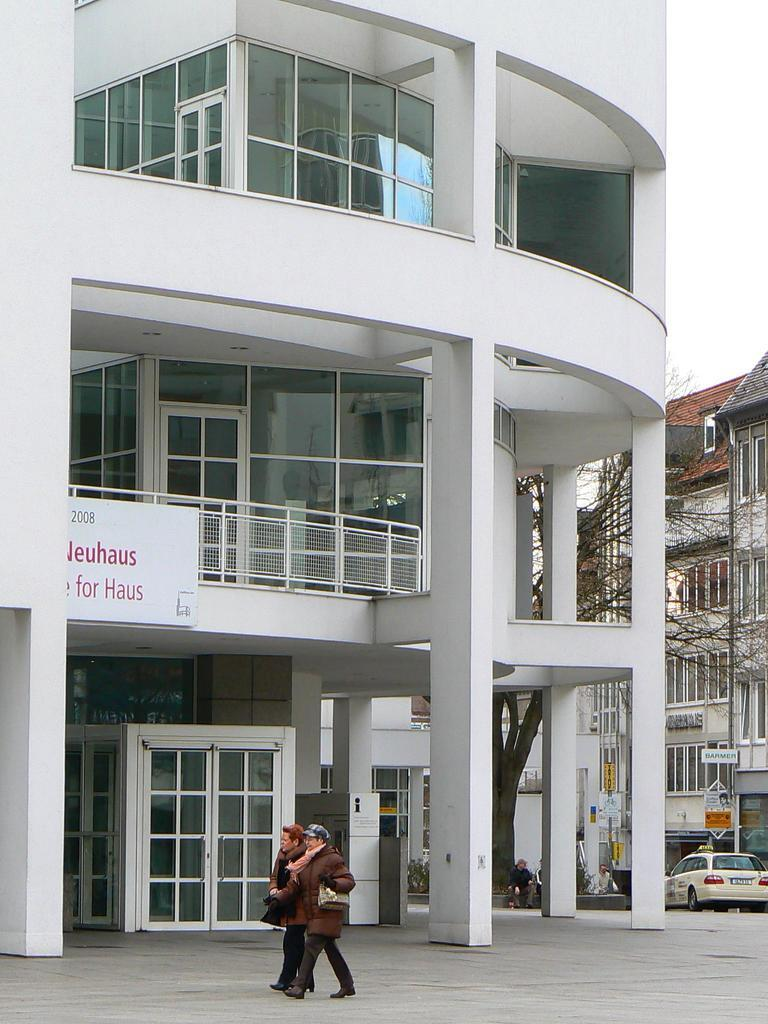What are the two people in the image doing? The two people in the image are walking on a pathway. What can be seen in the background of the image? There are buildings with name boards in the image. What natural element is present in the image? There is a tree in the image. What is the position of the person sitting in the image? There is a person sitting on the right side of the image. What mode of transportation is visible in the image? There is a car on the right side of the image. What type of bird is perched on the wren in the image? There is no bird or wren present in the image. What type of flag is being waved by the parent in the image? There is no parent or flag present in the image. 